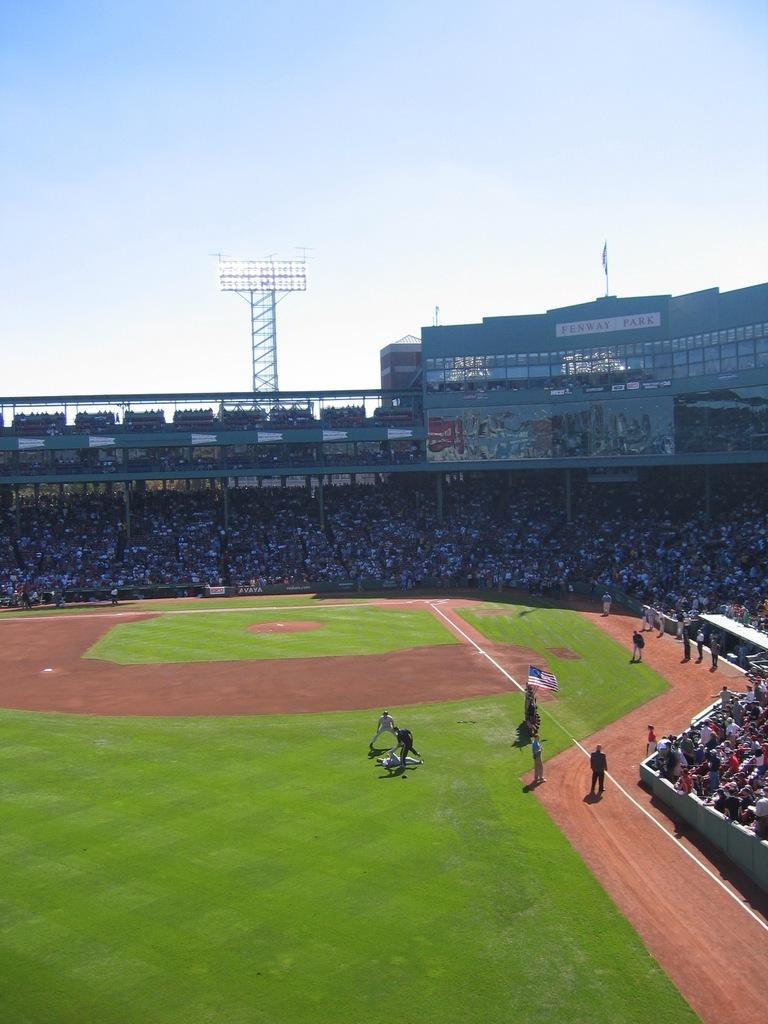What type of structure is visible in the image? There is a stadium in the image. What are the people in the image doing? People are sitting in the stadium. What type of surface is on the ground in the image? There is grass on the ground in the image. What type of marble is used to decorate the stadium in the image? There is no marble present in the image; the stadium and its surroundings are made of other materials. 